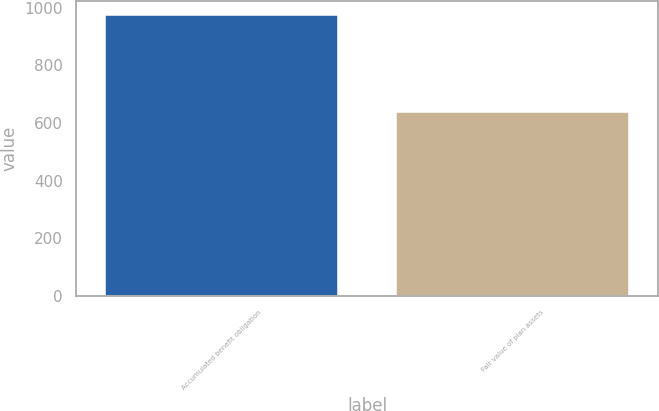Convert chart. <chart><loc_0><loc_0><loc_500><loc_500><bar_chart><fcel>Accumulated benefit obligation<fcel>Fair value of plan assets<nl><fcel>973.6<fcel>639<nl></chart> 